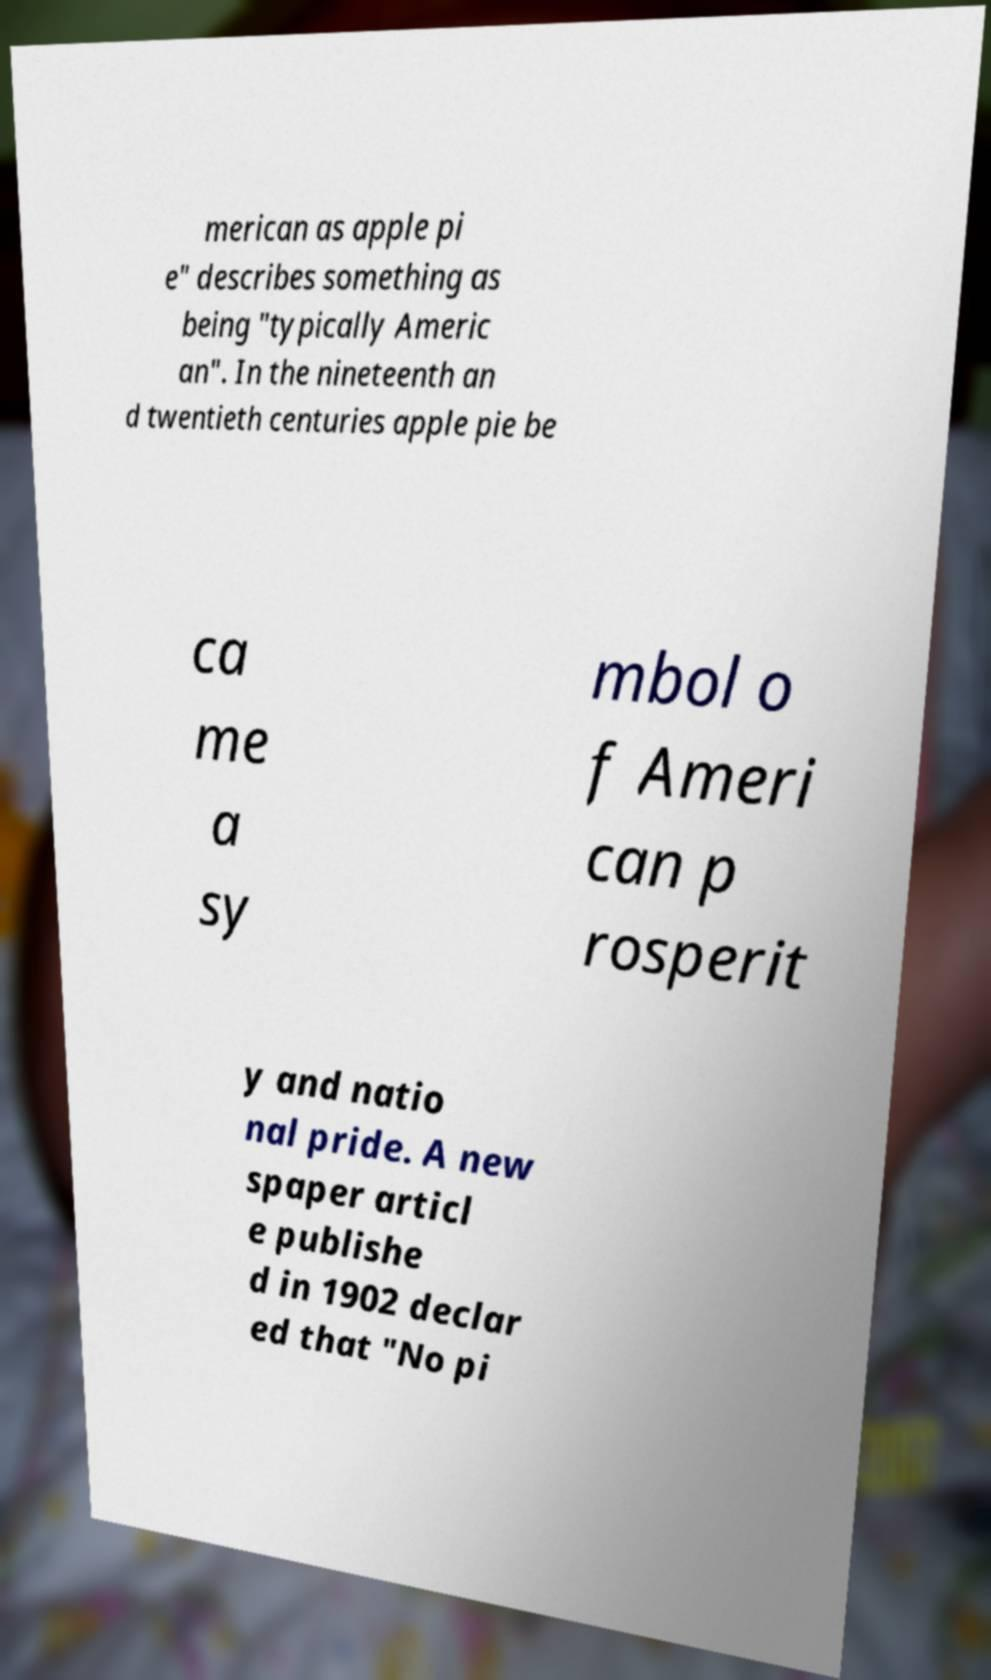Please read and relay the text visible in this image. What does it say? merican as apple pi e" describes something as being "typically Americ an". In the nineteenth an d twentieth centuries apple pie be ca me a sy mbol o f Ameri can p rosperit y and natio nal pride. A new spaper articl e publishe d in 1902 declar ed that "No pi 